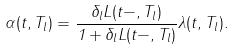Convert formula to latex. <formula><loc_0><loc_0><loc_500><loc_500>\alpha ( t , T _ { l } ) = \frac { \delta _ { l } L ( t - , T _ { l } ) } { 1 + \delta _ { l } L ( t - , T _ { l } ) } \lambda ( t , T _ { l } ) .</formula> 